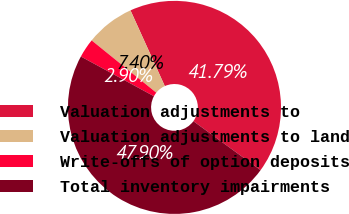<chart> <loc_0><loc_0><loc_500><loc_500><pie_chart><fcel>Valuation adjustments to<fcel>Valuation adjustments to land<fcel>Write-offs of option deposits<fcel>Total inventory impairments<nl><fcel>41.79%<fcel>7.4%<fcel>2.9%<fcel>47.9%<nl></chart> 